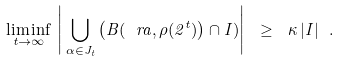Convert formula to latex. <formula><loc_0><loc_0><loc_500><loc_500>\liminf _ { t \to \infty } \, \left | \, { \bigcup _ { \alpha \in J _ { t } } } \left ( B ( \ r a , \rho ( 2 ^ { t } ) \right ) \cap I ) \right | \ \geq \ \kappa \, | I | \ .</formula> 